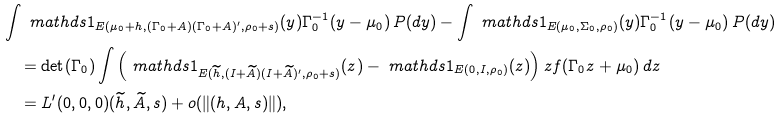<formula> <loc_0><loc_0><loc_500><loc_500>& \int \ m a t h d s { 1 } _ { E ( \mu _ { 0 } + h , ( \Gamma _ { 0 } + A ) ( \Gamma _ { 0 } + A ) ^ { \prime } , \rho _ { 0 } + s ) } ( y ) \Gamma _ { 0 } ^ { - 1 } ( y - \mu _ { 0 } ) \, P ( d y ) - \int \ m a t h d s { 1 } _ { E ( \mu _ { 0 } , \Sigma _ { 0 } , \rho _ { 0 } ) } ( y ) \Gamma _ { 0 } ^ { - 1 } ( y - \mu _ { 0 } ) \, P ( d y ) \\ & \quad = \det ( \Gamma _ { 0 } ) \int \left ( \ m a t h d s { 1 } _ { E ( \widetilde { h } , ( I + \widetilde { A } ) ( I + \widetilde { A } ) ^ { \prime } , \rho _ { 0 } + s ) } ( z ) - \ m a t h d s { 1 } _ { E ( 0 , I , \rho _ { 0 } ) } ( z ) \right ) z f ( \Gamma _ { 0 } z + \mu _ { 0 } ) \, d z \\ & \quad = L ^ { \prime } ( 0 , 0 , 0 ) ( \widetilde { h } , \widetilde { A } , s ) + o ( \| ( h , A , s ) \| ) ,</formula> 